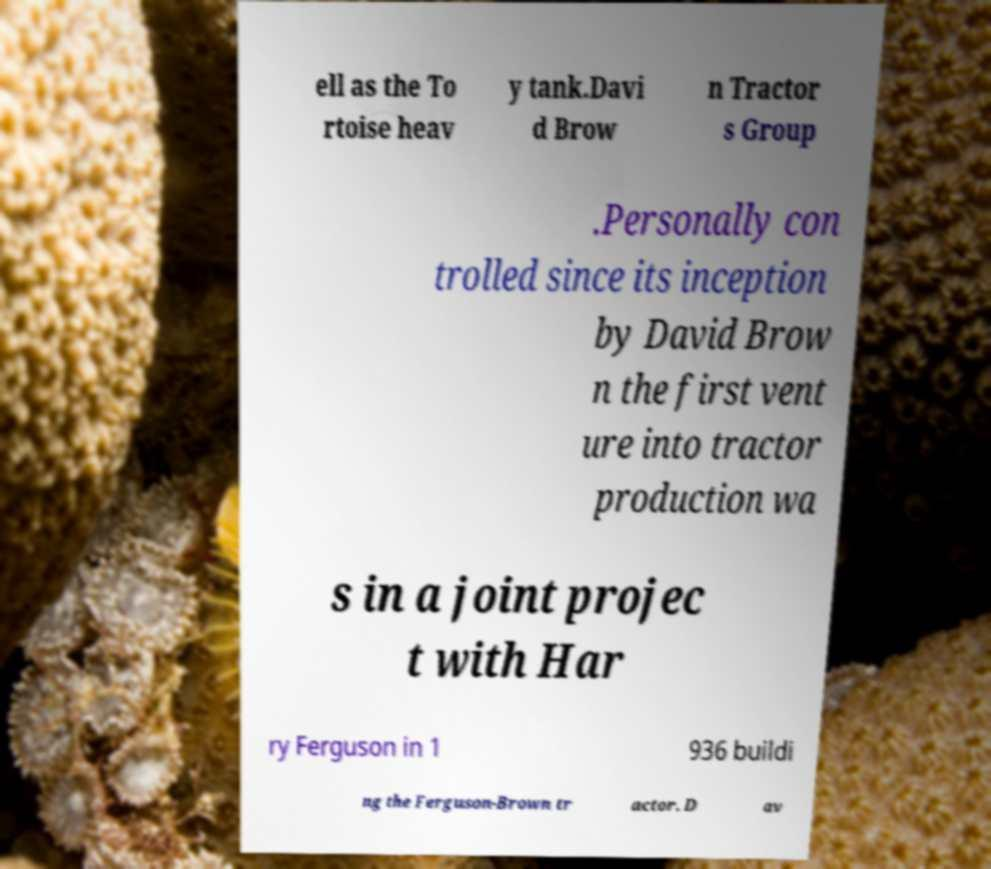For documentation purposes, I need the text within this image transcribed. Could you provide that? ell as the To rtoise heav y tank.Davi d Brow n Tractor s Group .Personally con trolled since its inception by David Brow n the first vent ure into tractor production wa s in a joint projec t with Har ry Ferguson in 1 936 buildi ng the Ferguson-Brown tr actor. D av 